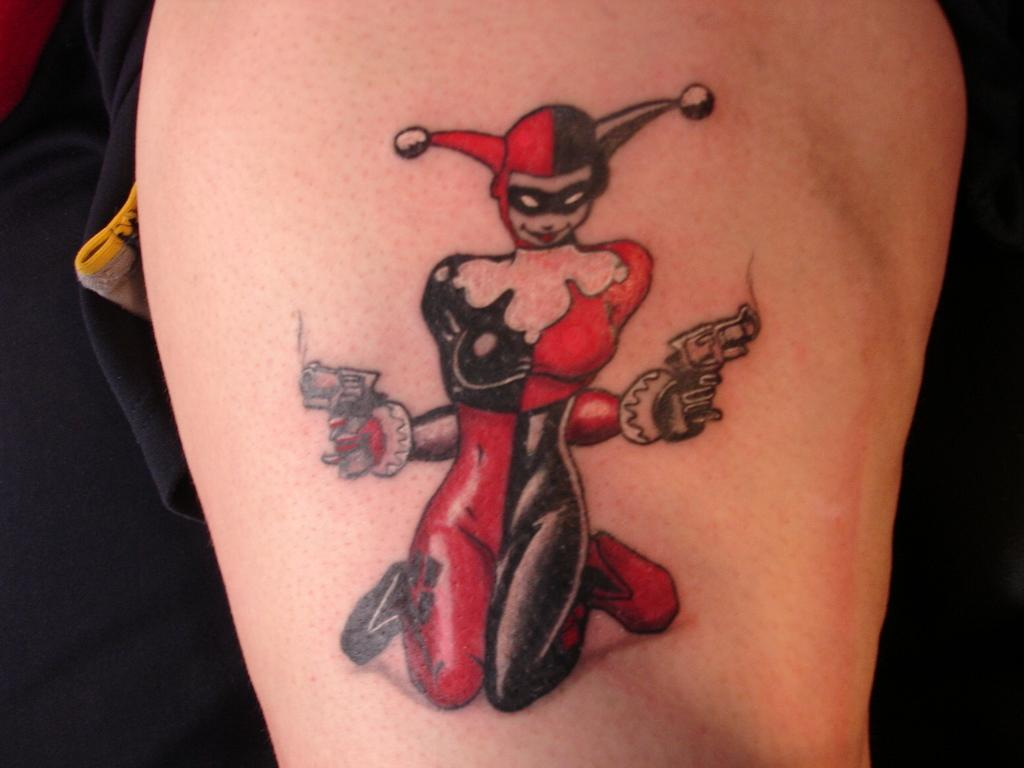What is present on the hand in the image? There is a tattoo on the hand in the image. What is the design of the tattoo on the hand? The tattoo is of a cartoon. What experience does the hand have with the story of the cartoon depicted in the tattoo? The image does not provide any information about the hand's experience with the story of the cartoon depicted in the tattoo. 